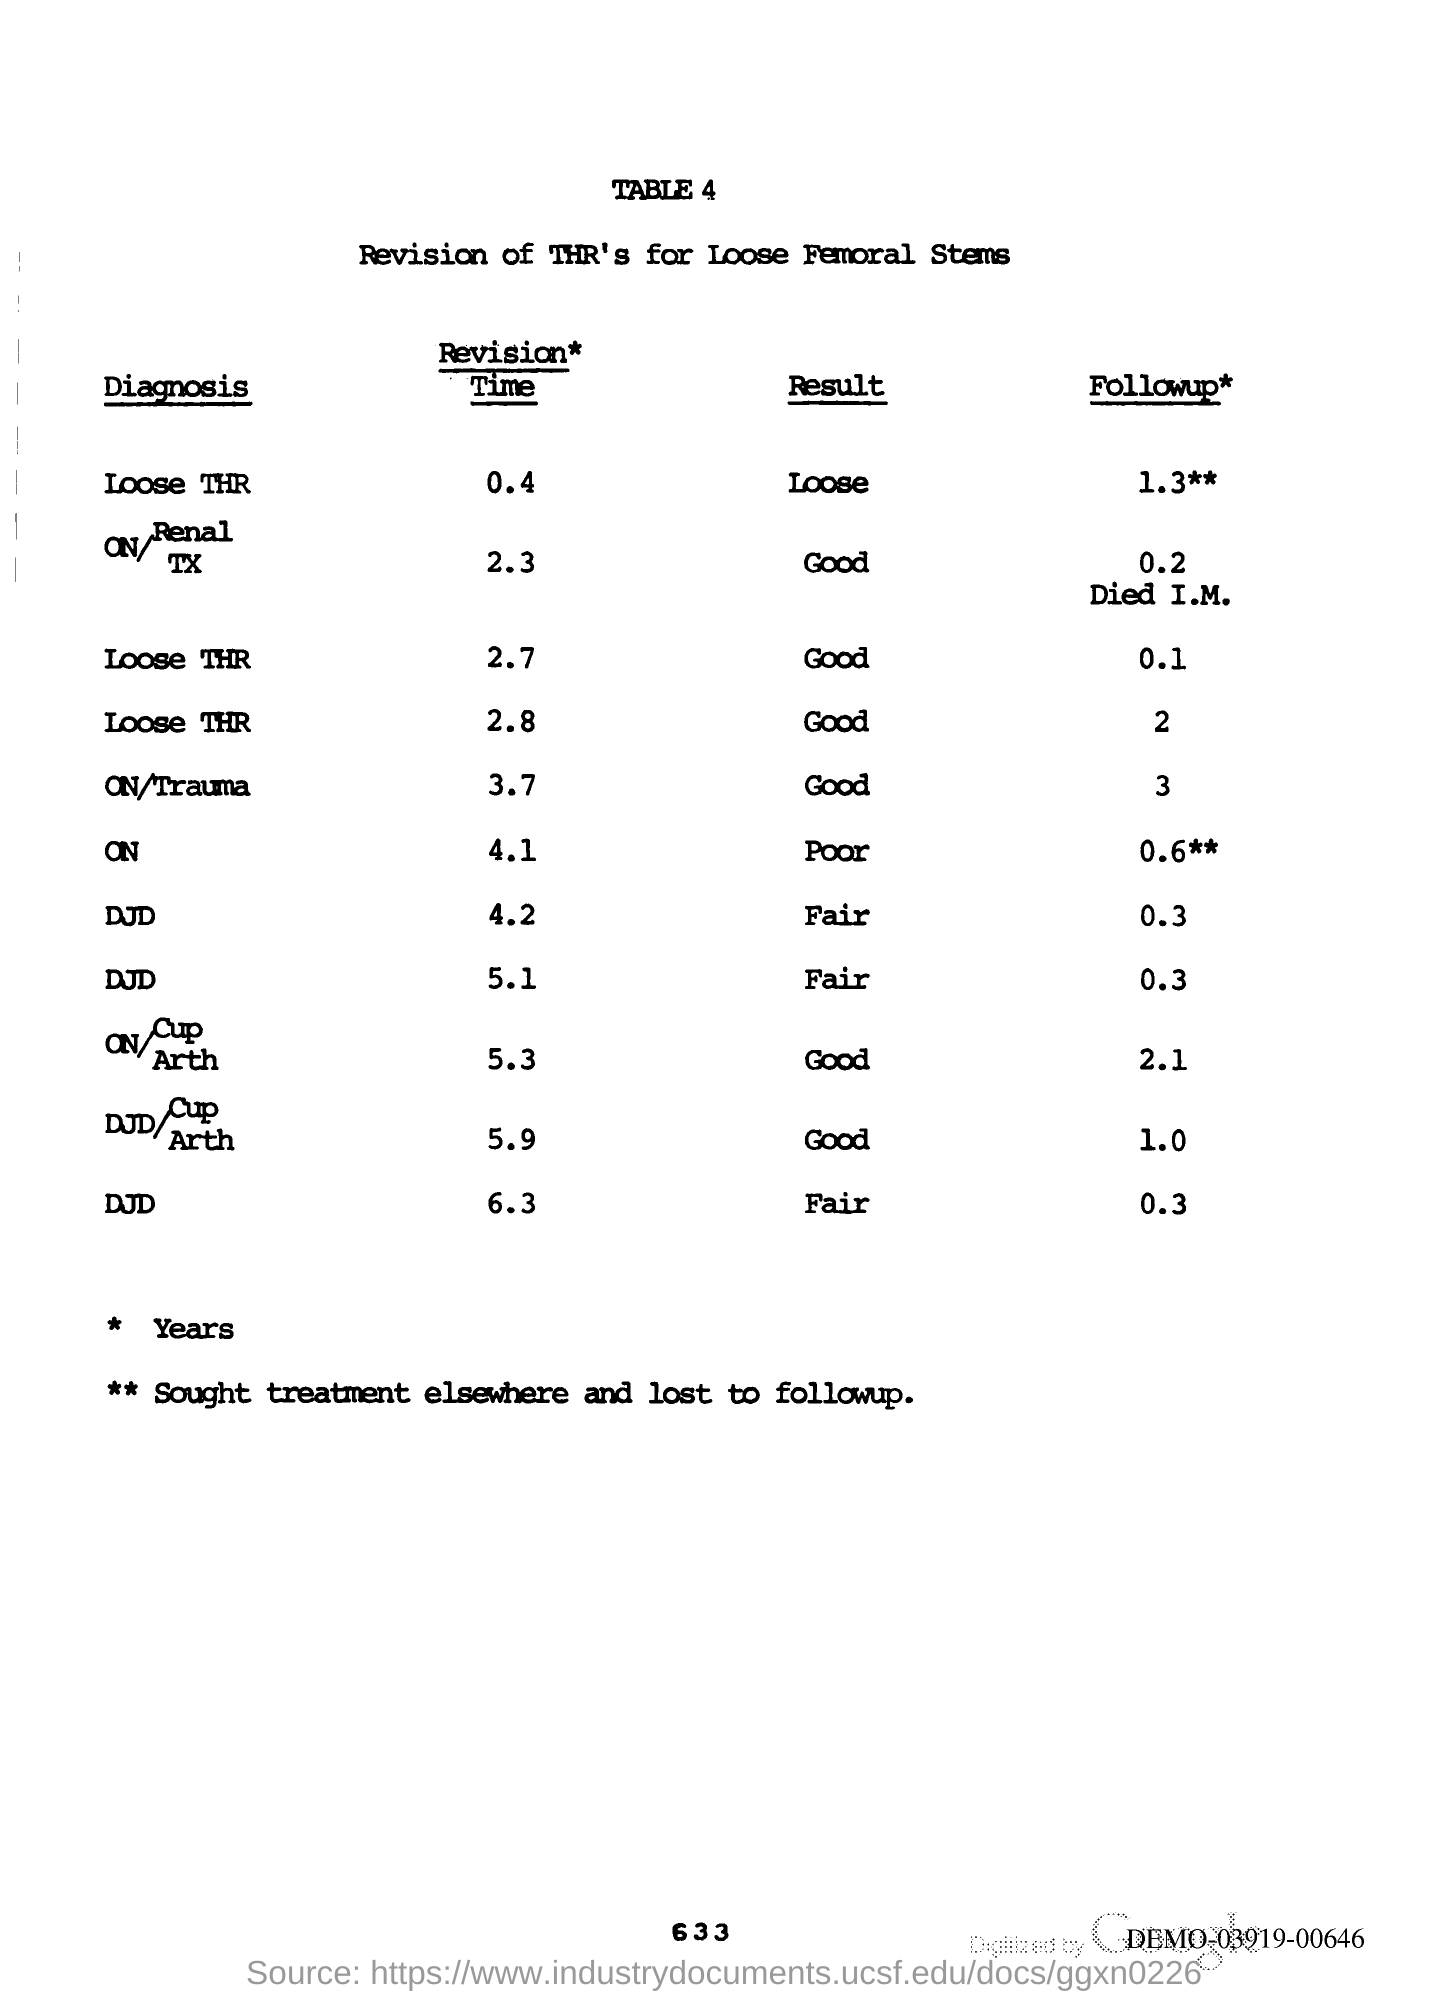Point out several critical features in this image. The page number is 633. 